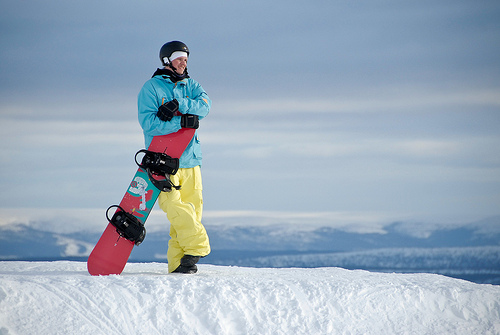Describe the environment surrounding the person. The individual in the image is surrounded by an expansive snowy landscape with gentle slopes. The horizon showcases mountain silhouettes against a soft blue sky, suggesting a tranquil and vast winter setting ideal for snowboarding. What time of day does it seem to be in the image? Given the even lighting and absence of long shadows, it appears to be midday, which typically offers optimal visibility and temperatures for snowboarding. 